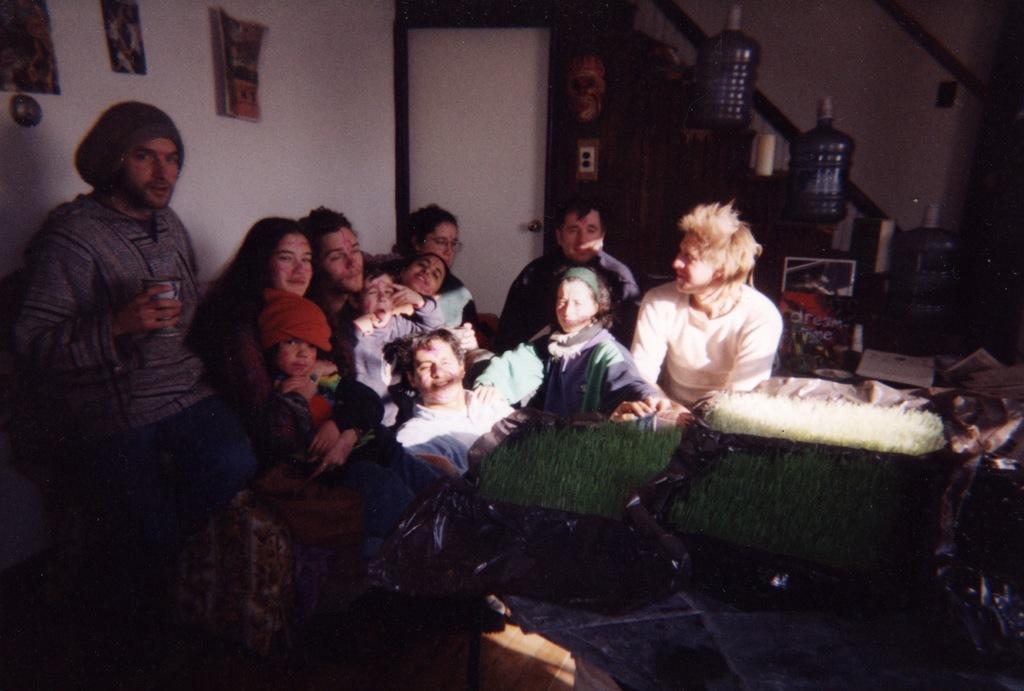Can you describe this image briefly? In this image I can see few children and few people where one is standing and rest all are sitting. On the right side of this image I can see few green colour things and in the background I can see few water can. On the top left side of this image I can see few posts on the wall and I can see this image is little bit in dark. I can also see a white colour door in the background. 